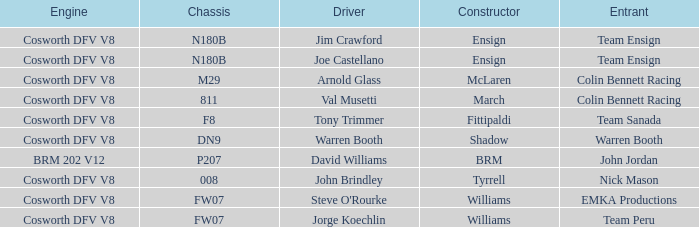Can you parse all the data within this table? {'header': ['Engine', 'Chassis', 'Driver', 'Constructor', 'Entrant'], 'rows': [['Cosworth DFV V8', 'N180B', 'Jim Crawford', 'Ensign', 'Team Ensign'], ['Cosworth DFV V8', 'N180B', 'Joe Castellano', 'Ensign', 'Team Ensign'], ['Cosworth DFV V8', 'M29', 'Arnold Glass', 'McLaren', 'Colin Bennett Racing'], ['Cosworth DFV V8', '811', 'Val Musetti', 'March', 'Colin Bennett Racing'], ['Cosworth DFV V8', 'F8', 'Tony Trimmer', 'Fittipaldi', 'Team Sanada'], ['Cosworth DFV V8', 'DN9', 'Warren Booth', 'Shadow', 'Warren Booth'], ['BRM 202 V12', 'P207', 'David Williams', 'BRM', 'John Jordan'], ['Cosworth DFV V8', '008', 'John Brindley', 'Tyrrell', 'Nick Mason'], ['Cosworth DFV V8', 'FW07', "Steve O'Rourke", 'Williams', 'EMKA Productions'], ['Cosworth DFV V8', 'FW07', 'Jorge Koechlin', 'Williams', 'Team Peru']]} What framework is used in the shadow assembled car? DN9. 